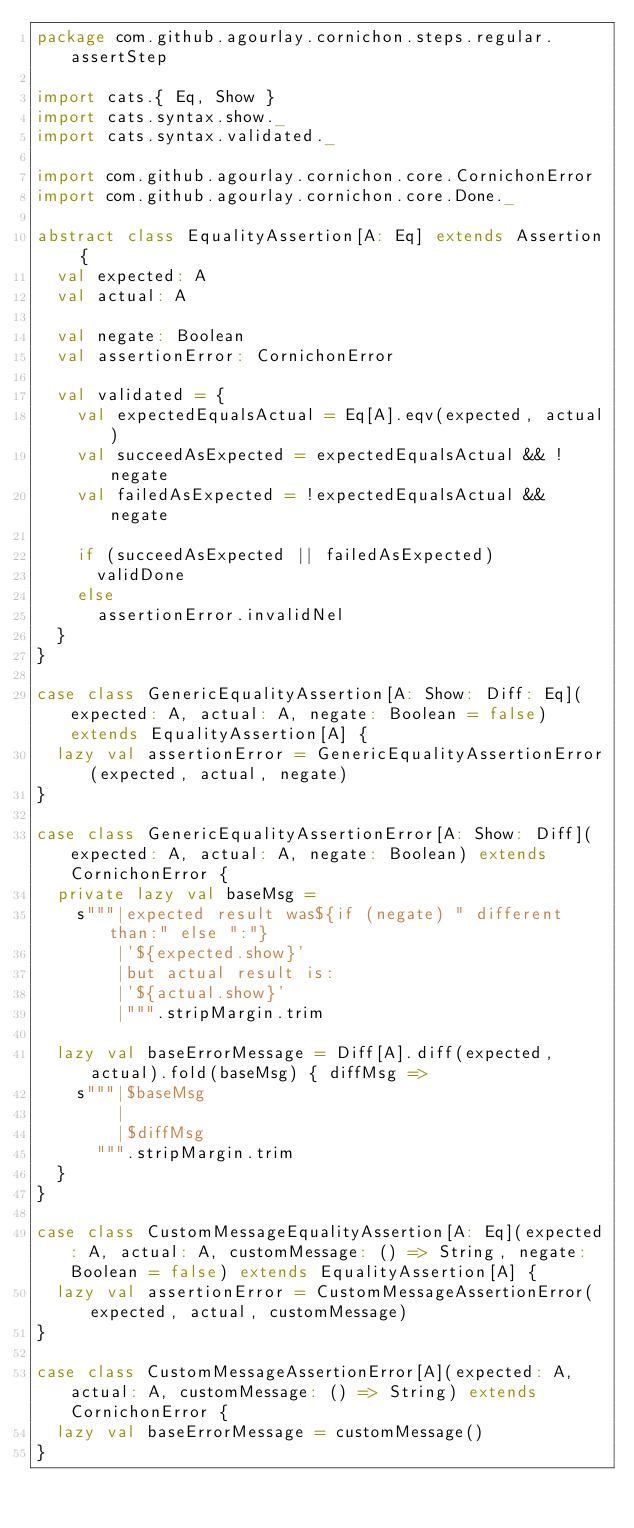Convert code to text. <code><loc_0><loc_0><loc_500><loc_500><_Scala_>package com.github.agourlay.cornichon.steps.regular.assertStep

import cats.{ Eq, Show }
import cats.syntax.show._
import cats.syntax.validated._

import com.github.agourlay.cornichon.core.CornichonError
import com.github.agourlay.cornichon.core.Done._

abstract class EqualityAssertion[A: Eq] extends Assertion {
  val expected: A
  val actual: A

  val negate: Boolean
  val assertionError: CornichonError

  val validated = {
    val expectedEqualsActual = Eq[A].eqv(expected, actual)
    val succeedAsExpected = expectedEqualsActual && !negate
    val failedAsExpected = !expectedEqualsActual && negate

    if (succeedAsExpected || failedAsExpected)
      validDone
    else
      assertionError.invalidNel
  }
}

case class GenericEqualityAssertion[A: Show: Diff: Eq](expected: A, actual: A, negate: Boolean = false) extends EqualityAssertion[A] {
  lazy val assertionError = GenericEqualityAssertionError(expected, actual, negate)
}

case class GenericEqualityAssertionError[A: Show: Diff](expected: A, actual: A, negate: Boolean) extends CornichonError {
  private lazy val baseMsg =
    s"""|expected result was${if (negate) " different than:" else ":"}
        |'${expected.show}'
        |but actual result is:
        |'${actual.show}'
        |""".stripMargin.trim

  lazy val baseErrorMessage = Diff[A].diff(expected, actual).fold(baseMsg) { diffMsg =>
    s"""|$baseMsg
        |
        |$diffMsg
      """.stripMargin.trim
  }
}

case class CustomMessageEqualityAssertion[A: Eq](expected: A, actual: A, customMessage: () => String, negate: Boolean = false) extends EqualityAssertion[A] {
  lazy val assertionError = CustomMessageAssertionError(expected, actual, customMessage)
}

case class CustomMessageAssertionError[A](expected: A, actual: A, customMessage: () => String) extends CornichonError {
  lazy val baseErrorMessage = customMessage()
}</code> 